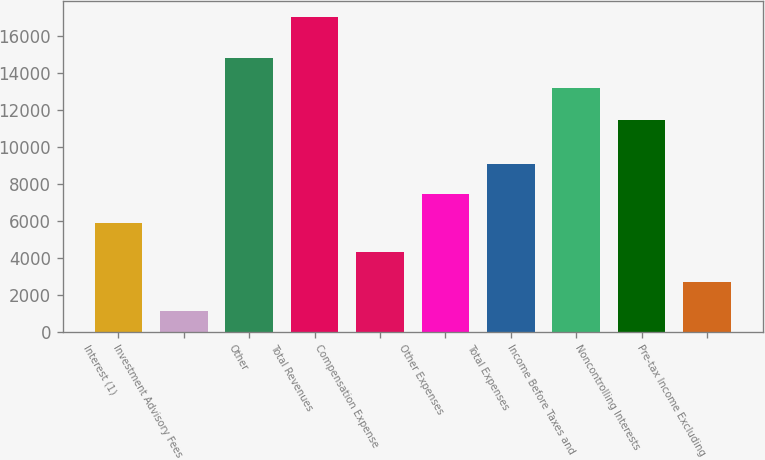Convert chart. <chart><loc_0><loc_0><loc_500><loc_500><bar_chart><fcel>Interest (1)<fcel>Investment Advisory Fees<fcel>Other<fcel>Total Revenues<fcel>Compensation Expense<fcel>Other Expenses<fcel>Total Expenses<fcel>Income Before Taxes and<fcel>Noncontrolling Interests<fcel>Pre-tax Income Excluding<nl><fcel>5878.7<fcel>1100<fcel>14785.9<fcel>17029<fcel>4285.8<fcel>7471.6<fcel>9064.5<fcel>13193<fcel>11465<fcel>2692.9<nl></chart> 